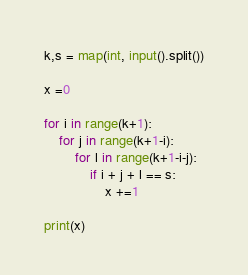Convert code to text. <code><loc_0><loc_0><loc_500><loc_500><_Python_>k,s = map(int, input().split())

x =0

for i in range(k+1):
    for j in range(k+1-i):
        for l in range(k+1-i-j):
            if i + j + l == s:
                x +=1

print(x)</code> 